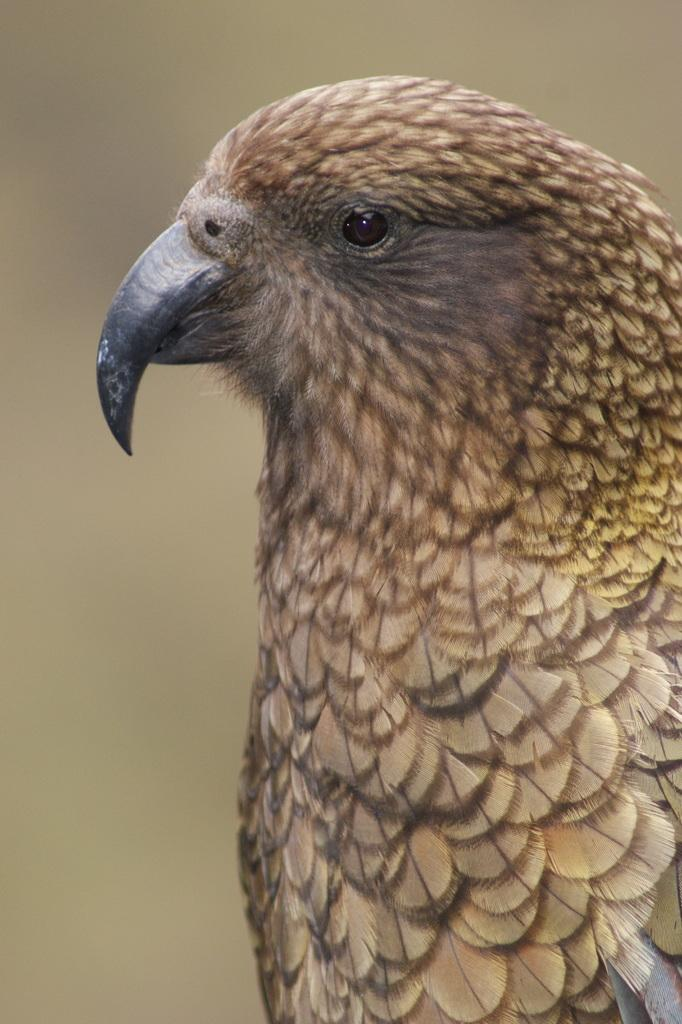What type of animal is in the image? There is a bird in the image. Can you describe the background of the image? The background of the image is blurred. How many giraffes can be seen in the image? There are no giraffes present in the image; it features a bird. What letters are visible on the bird in the image? There are no letters visible on the bird in the image. 